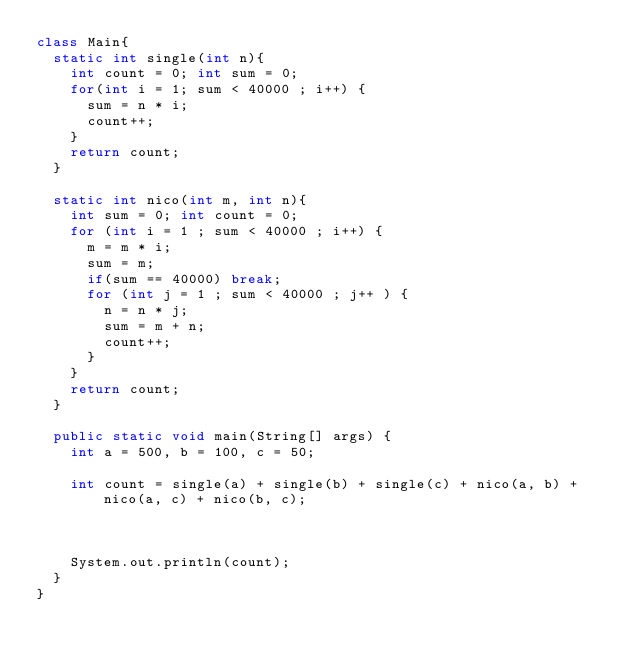Convert code to text. <code><loc_0><loc_0><loc_500><loc_500><_Java_>class Main{
  static int single(int n){
    int count = 0; int sum = 0;
    for(int i = 1; sum < 40000 ; i++) {
      sum = n * i;
      count++;
    }
    return count;
  }

  static int nico(int m, int n){
    int sum = 0; int count = 0;
    for (int i = 1 ; sum < 40000 ; i++) {
      m = m * i;
      sum = m;
      if(sum == 40000) break;
      for (int j = 1 ; sum < 40000 ; j++ ) {
        n = n * j;
        sum = m + n;
        count++;
      }
    }
    return count;
  }

  public static void main(String[] args) {
    int a = 500, b = 100, c = 50;

    int count = single(a) + single(b) + single(c) + nico(a, b) + nico(a, c) + nico(b, c);



    System.out.println(count);
  }
}
</code> 